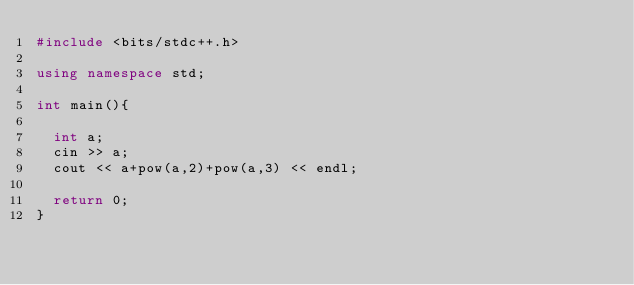Convert code to text. <code><loc_0><loc_0><loc_500><loc_500><_C++_>#include <bits/stdc++.h>

using namespace std;

int main(){

	int a;
	cin >> a;
	cout << a+pow(a,2)+pow(a,3) << endl;

	return 0;
}
</code> 